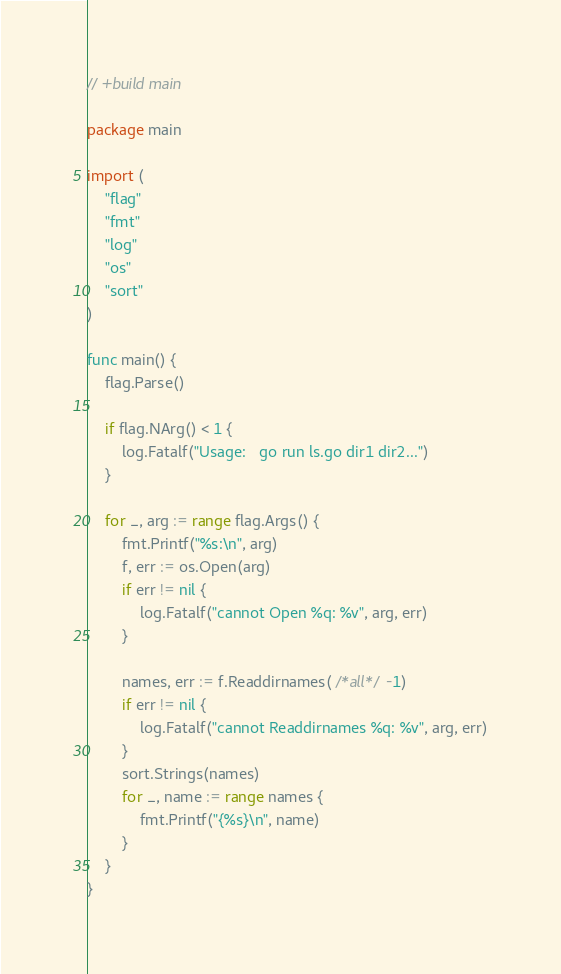Convert code to text. <code><loc_0><loc_0><loc_500><loc_500><_Go_>// +build main

package main

import (
	"flag"
	"fmt"
	"log"
	"os"
	"sort"
)

func main() {
	flag.Parse()

	if flag.NArg() < 1 {
		log.Fatalf("Usage:   go run ls.go dir1 dir2...")
	}

	for _, arg := range flag.Args() {
		fmt.Printf("%s:\n", arg)
		f, err := os.Open(arg)
		if err != nil {
			log.Fatalf("cannot Open %q: %v", arg, err)
		}

		names, err := f.Readdirnames( /*all*/ -1)
		if err != nil {
			log.Fatalf("cannot Readdirnames %q: %v", arg, err)
		}
		sort.Strings(names)
		for _, name := range names {
			fmt.Printf("{%s}\n", name)
		}
	}
}
</code> 